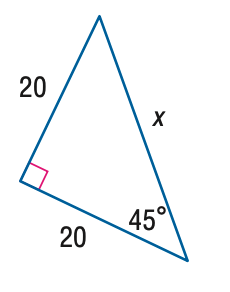Answer the mathemtical geometry problem and directly provide the correct option letter.
Question: Find x.
Choices: A: 10 \sqrt { 2 } B: 20 \sqrt { 2 } C: 20 \sqrt { 3 } D: 40 B 